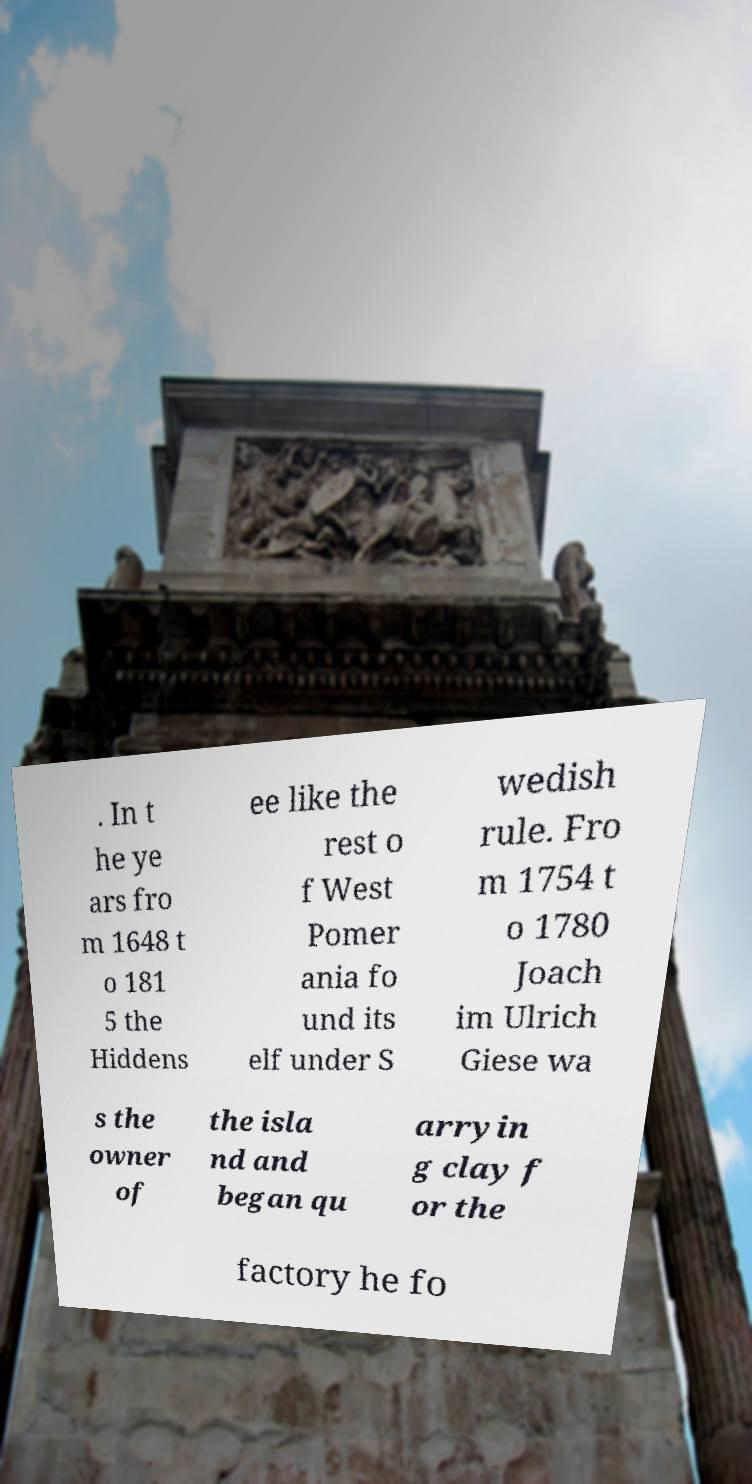Could you assist in decoding the text presented in this image and type it out clearly? . In t he ye ars fro m 1648 t o 181 5 the Hiddens ee like the rest o f West Pomer ania fo und its elf under S wedish rule. Fro m 1754 t o 1780 Joach im Ulrich Giese wa s the owner of the isla nd and began qu arryin g clay f or the factory he fo 